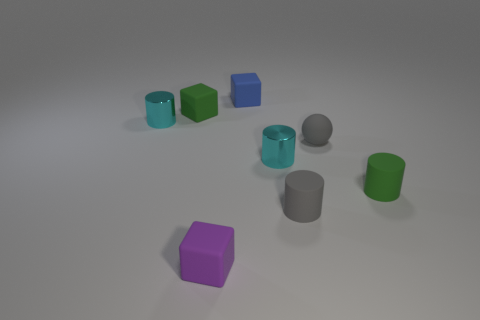What is the size of the blue matte thing that is the same shape as the purple matte object?
Ensure brevity in your answer.  Small. How many gray cylinders have the same material as the small sphere?
Provide a succinct answer. 1. What is the material of the purple thing?
Your answer should be compact. Rubber. The tiny green thing that is to the left of the tiny cylinder that is right of the small matte ball is what shape?
Ensure brevity in your answer.  Cube. What shape is the tiny green matte object behind the gray matte ball?
Offer a very short reply. Cube. What number of cubes have the same color as the small matte sphere?
Keep it short and to the point. 0. The tiny sphere is what color?
Your answer should be very brief. Gray. How many tiny gray rubber things are behind the green object behind the sphere?
Ensure brevity in your answer.  0. Do the gray ball and the green block have the same size?
Provide a short and direct response. Yes. Is there another rubber cube that has the same size as the green block?
Ensure brevity in your answer.  Yes. 